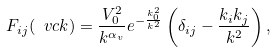<formula> <loc_0><loc_0><loc_500><loc_500>F _ { i j } ( \ v c { k } ) = \frac { V _ { 0 } ^ { 2 } } { k ^ { \alpha _ { v } } } e ^ { - \frac { k _ { 0 } ^ { 2 } } { k ^ { 2 } } } \left ( \delta _ { i j } - \frac { k _ { i } k _ { j } } { k ^ { 2 } } \right ) ,</formula> 